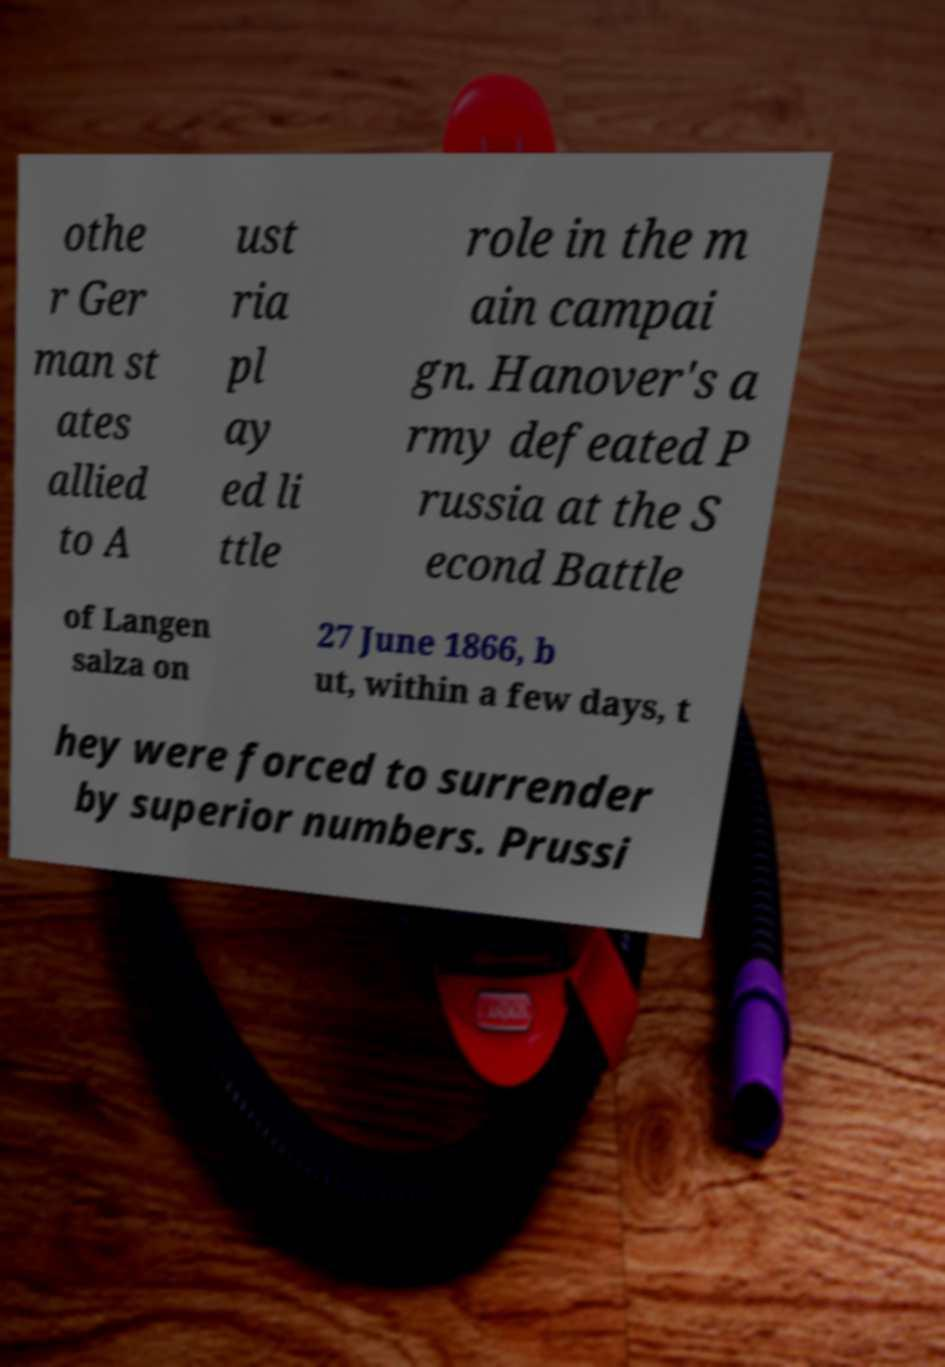Could you assist in decoding the text presented in this image and type it out clearly? othe r Ger man st ates allied to A ust ria pl ay ed li ttle role in the m ain campai gn. Hanover's a rmy defeated P russia at the S econd Battle of Langen salza on 27 June 1866, b ut, within a few days, t hey were forced to surrender by superior numbers. Prussi 